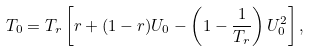<formula> <loc_0><loc_0><loc_500><loc_500>T _ { 0 } = T _ { r } \left [ r + ( 1 - r ) U _ { 0 } - \left ( 1 - \frac { 1 } { T _ { r } } \right ) U _ { 0 } ^ { 2 } \right ] ,</formula> 